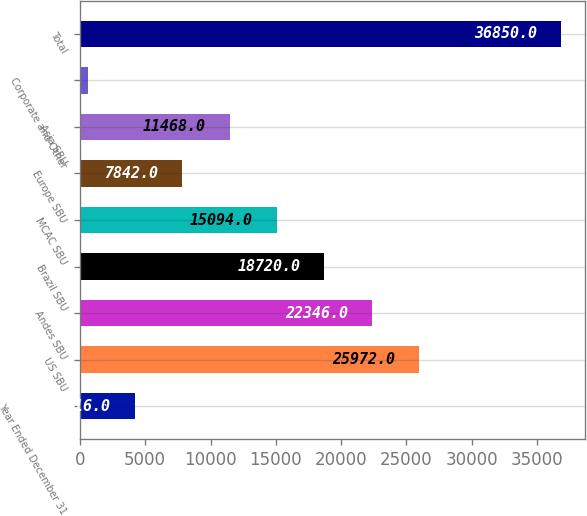Convert chart. <chart><loc_0><loc_0><loc_500><loc_500><bar_chart><fcel>Year Ended December 31<fcel>US SBU<fcel>Andes SBU<fcel>Brazil SBU<fcel>MCAC SBU<fcel>Europe SBU<fcel>Asia SBU<fcel>Corporate and Other<fcel>Total<nl><fcel>4216<fcel>25972<fcel>22346<fcel>18720<fcel>15094<fcel>7842<fcel>11468<fcel>590<fcel>36850<nl></chart> 